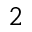Convert formula to latex. <formula><loc_0><loc_0><loc_500><loc_500>^ { 2 }</formula> 